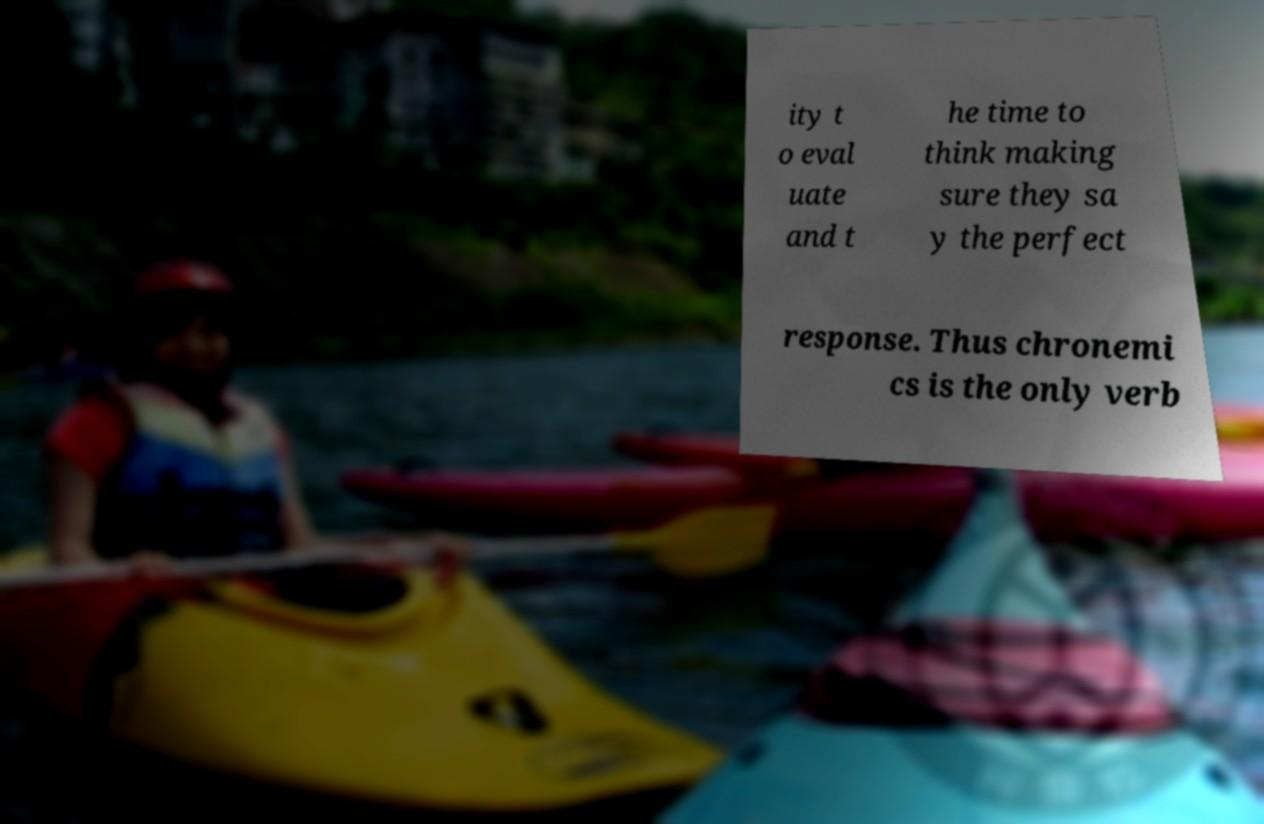Could you extract and type out the text from this image? ity t o eval uate and t he time to think making sure they sa y the perfect response. Thus chronemi cs is the only verb 